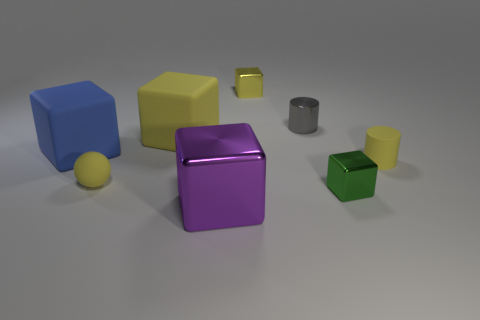There is another object that is the same shape as the gray metallic object; what is its color?
Provide a short and direct response. Yellow. Is there anything else that is the same shape as the small gray object?
Make the answer very short. Yes. Is the number of yellow metallic objects that are to the left of the large yellow rubber thing greater than the number of big blue rubber objects behind the big blue rubber thing?
Offer a very short reply. No. There is a yellow cube in front of the shiny cube behind the tiny matte thing to the left of the large purple metal object; what size is it?
Offer a terse response. Large. Are the small gray thing and the small yellow thing behind the blue cube made of the same material?
Make the answer very short. Yes. Is the shape of the big metal object the same as the green metallic thing?
Offer a terse response. Yes. How many other things are there of the same material as the small gray cylinder?
Provide a short and direct response. 3. How many large shiny objects are the same shape as the big blue rubber object?
Provide a short and direct response. 1. There is a small object that is both on the left side of the tiny green metallic object and in front of the blue thing; what is its color?
Your answer should be very brief. Yellow. What number of tiny yellow matte blocks are there?
Give a very brief answer. 0. 